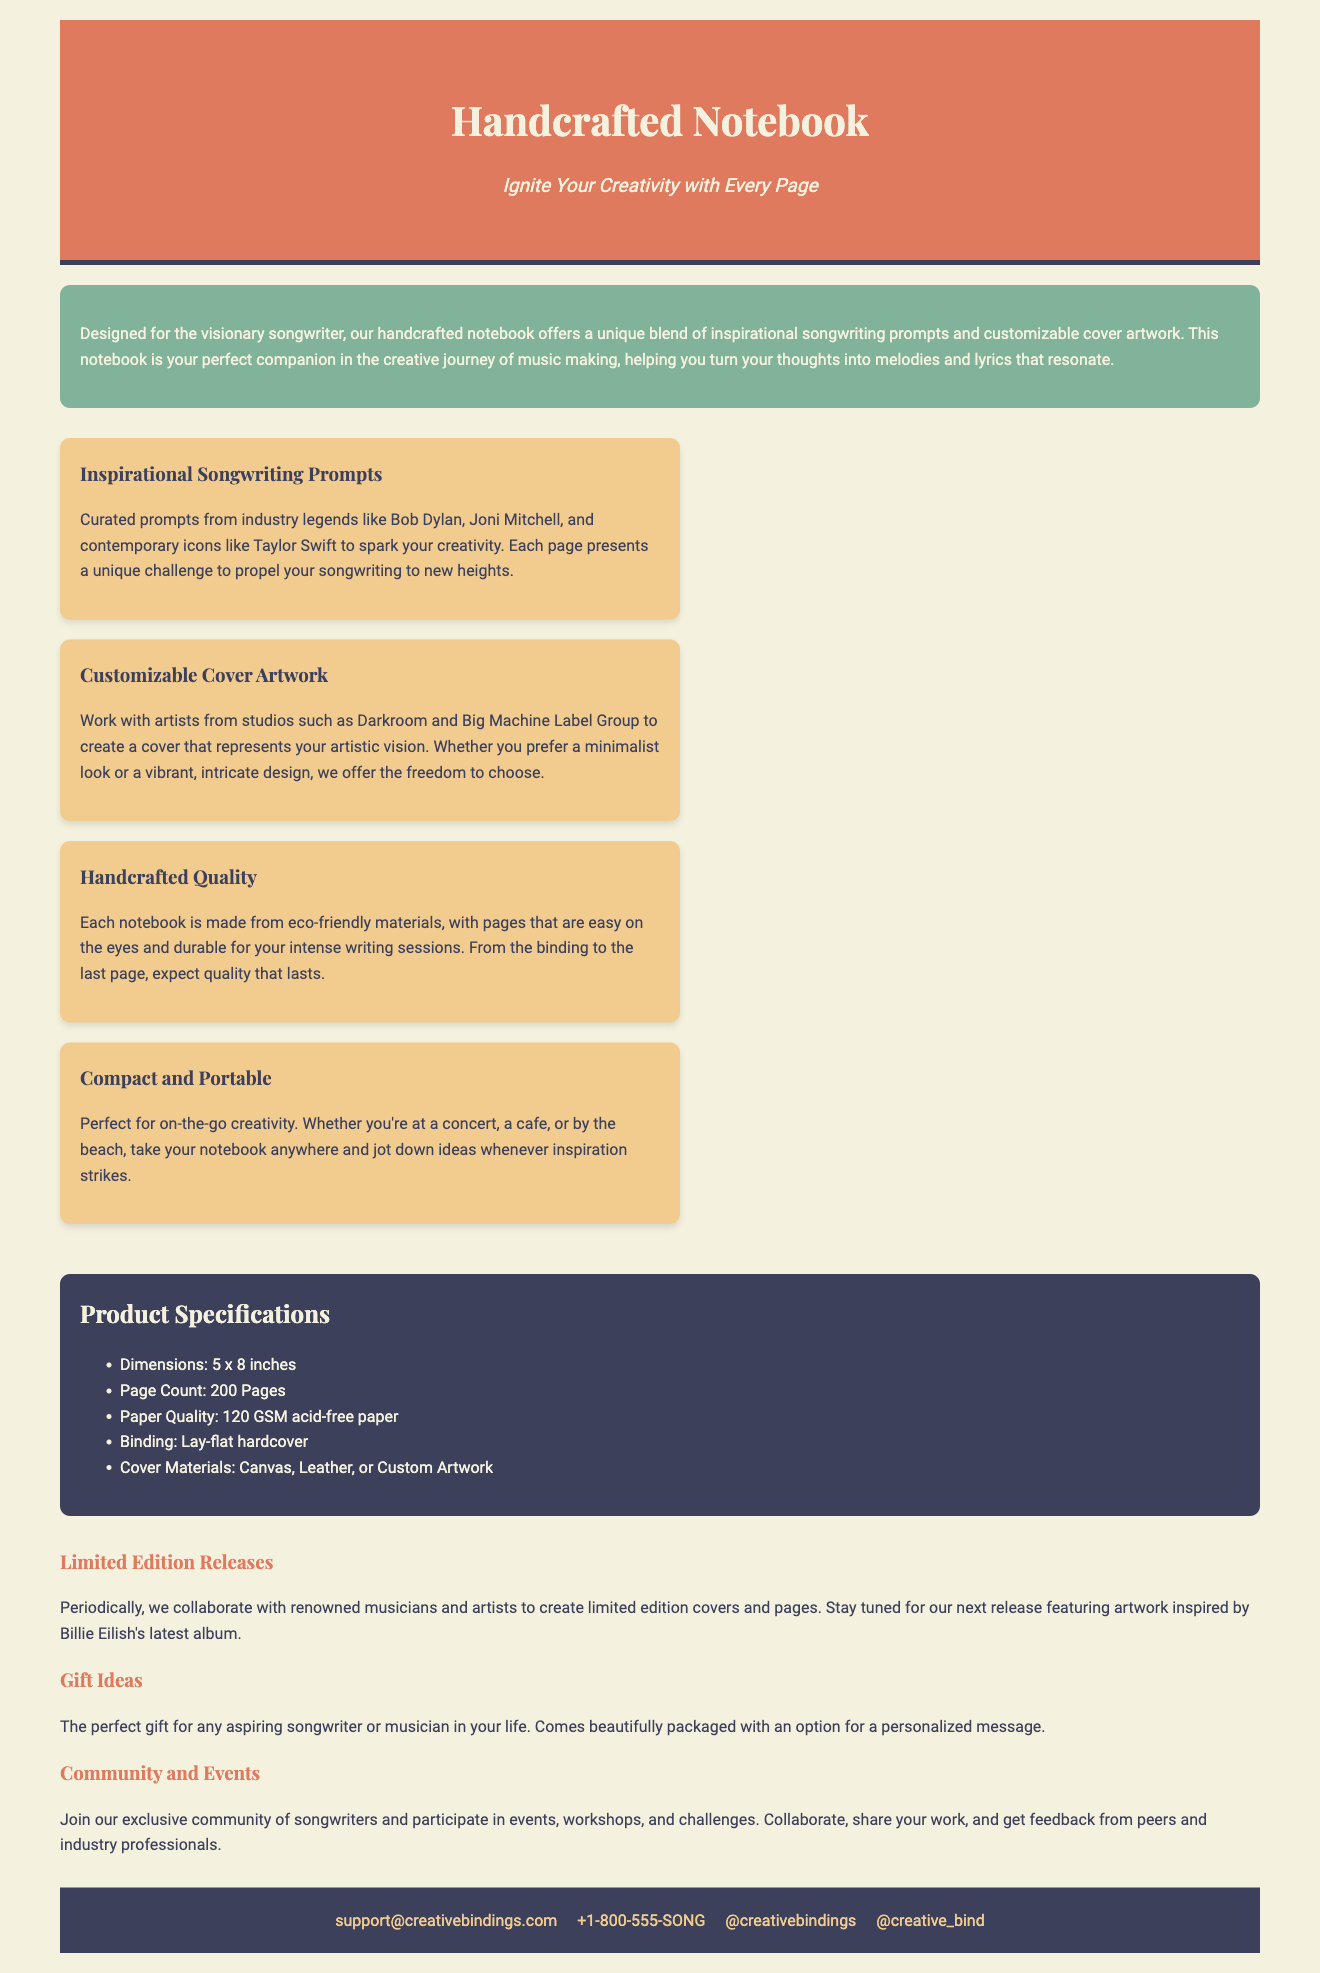What is the title of the notebook? The title of the notebook is presented prominently in the header section.
Answer: Handcrafted Notebook How many pages does the notebook have? The page count is specifically mentioned in the product specifications section.
Answer: 200 Pages What materials are used for the cover? The cover materials are listed in the product specifications, highlighting the options available.
Answer: Canvas, Leather, or Custom Artwork Who are some of the industry legends mentioned for the prompts? The description of the features includes examples of legendary songwriters who inspired the prompts.
Answer: Bob Dylan, Joni Mitchell, Taylor Swift What is the size of the notebook? The dimensions of the notebook are provided in the product specifications section.
Answer: 5 x 8 inches What kind of community opportunities do users have? The additional info section mentions the community aspect and events associated with the product.
Answer: Events, workshops, and challenges What kind of prompts does the notebook include? The features section describes the content of the prompts included in the notebook.
Answer: Inspirational Songwriting Prompts When can customers expect limited edition releases? The mention of limited edition releases indicates timings linked with collaborations.
Answer: Periodically What describes the binding of the notebook? The specifications detail the binding style used for the notebook.
Answer: Lay-flat hardcover 